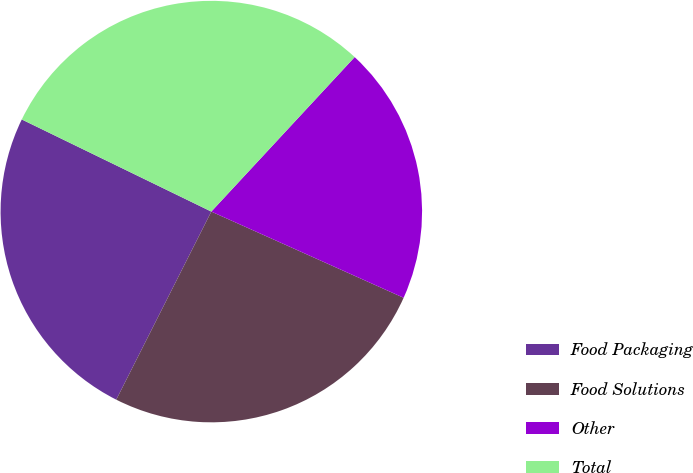Convert chart to OTSL. <chart><loc_0><loc_0><loc_500><loc_500><pie_chart><fcel>Food Packaging<fcel>Food Solutions<fcel>Other<fcel>Total<nl><fcel>24.75%<fcel>25.74%<fcel>19.8%<fcel>29.7%<nl></chart> 